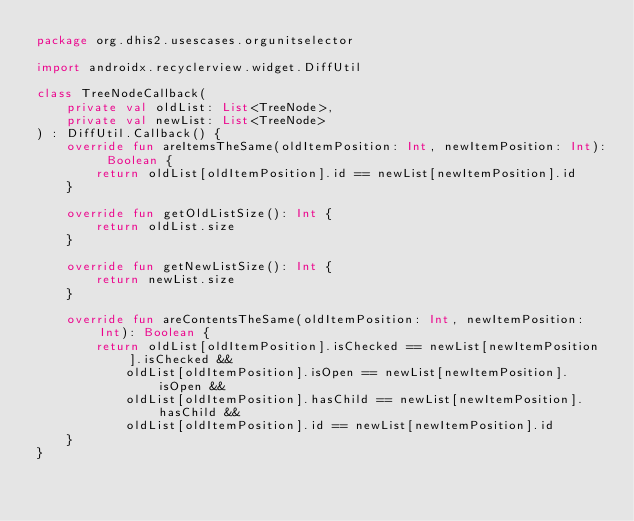Convert code to text. <code><loc_0><loc_0><loc_500><loc_500><_Kotlin_>package org.dhis2.usescases.orgunitselector

import androidx.recyclerview.widget.DiffUtil

class TreeNodeCallback(
    private val oldList: List<TreeNode>,
    private val newList: List<TreeNode>
) : DiffUtil.Callback() {
    override fun areItemsTheSame(oldItemPosition: Int, newItemPosition: Int): Boolean {
        return oldList[oldItemPosition].id == newList[newItemPosition].id
    }

    override fun getOldListSize(): Int {
        return oldList.size
    }

    override fun getNewListSize(): Int {
        return newList.size
    }

    override fun areContentsTheSame(oldItemPosition: Int, newItemPosition: Int): Boolean {
        return oldList[oldItemPosition].isChecked == newList[newItemPosition].isChecked &&
            oldList[oldItemPosition].isOpen == newList[newItemPosition].isOpen &&
            oldList[oldItemPosition].hasChild == newList[newItemPosition].hasChild &&
            oldList[oldItemPosition].id == newList[newItemPosition].id
    }
}
</code> 